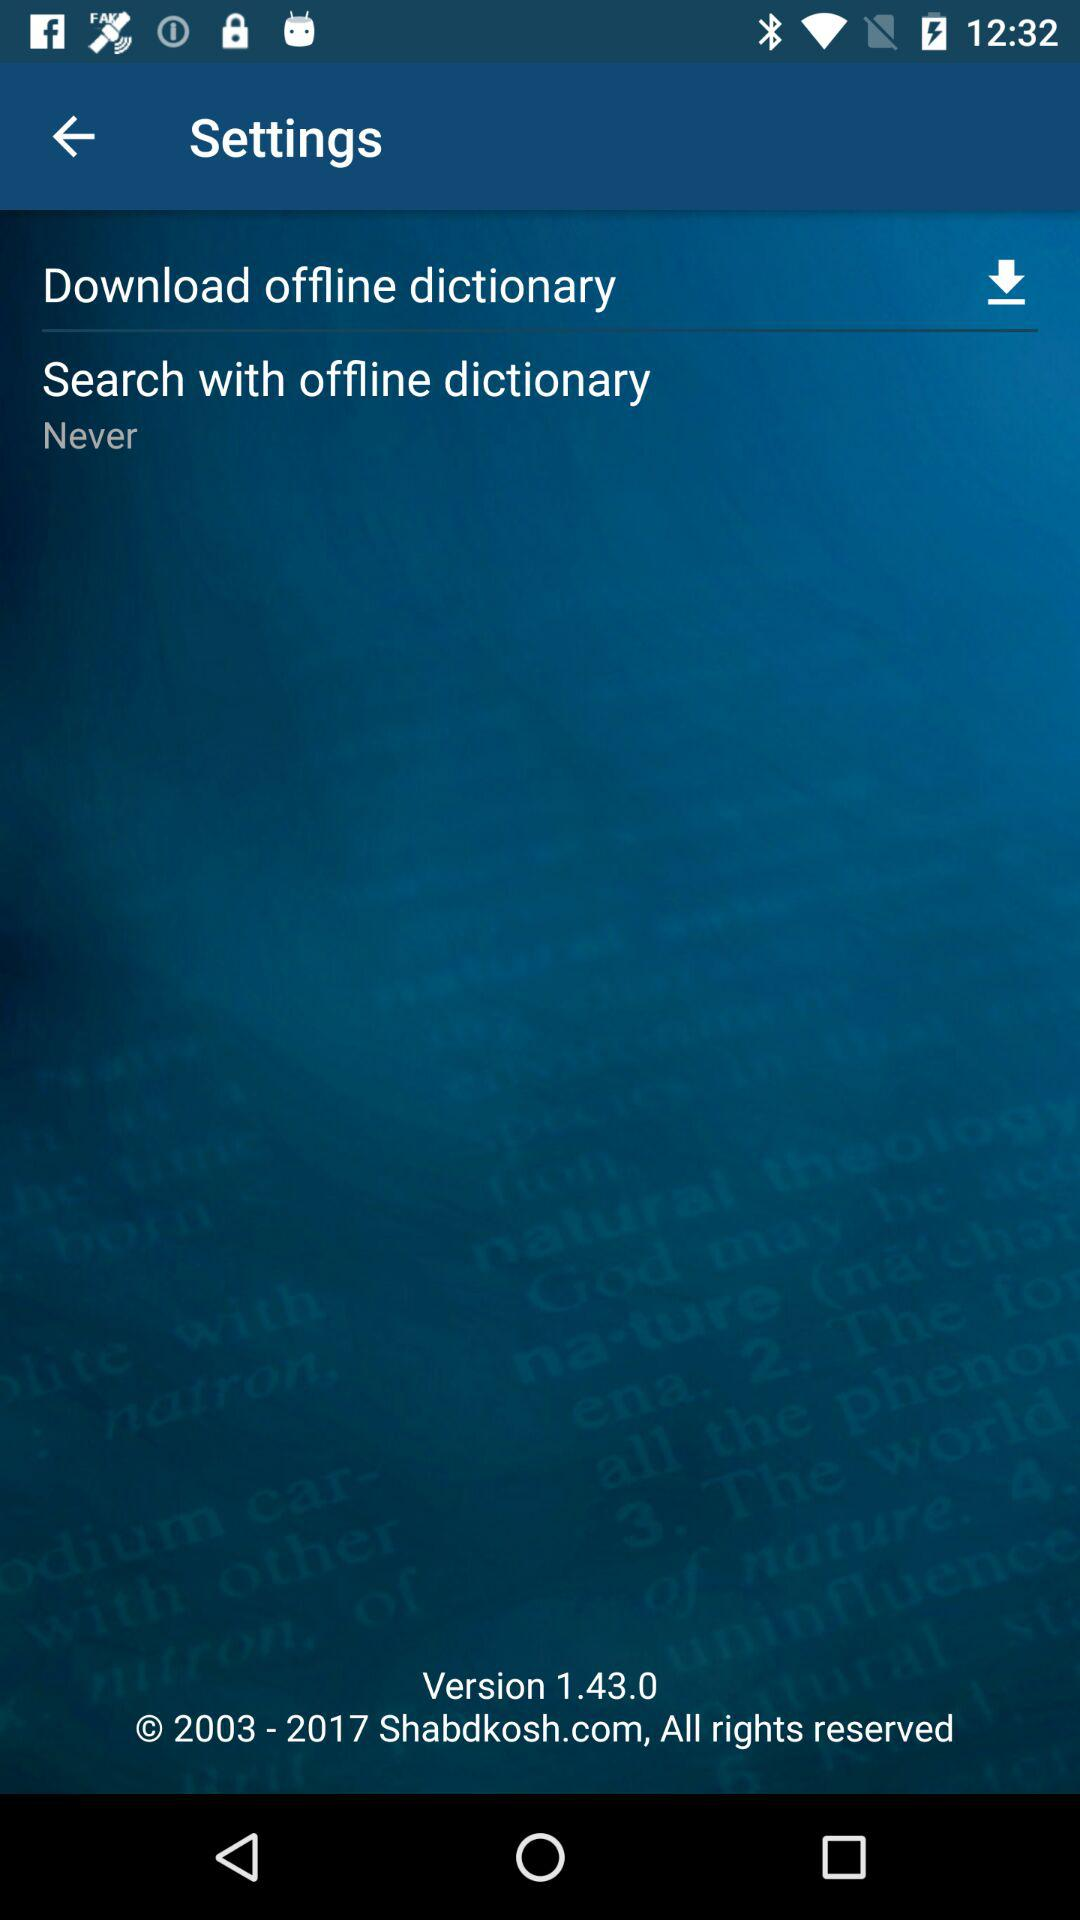What is the copyright year? The copyright years are from 2003 to 2017. 